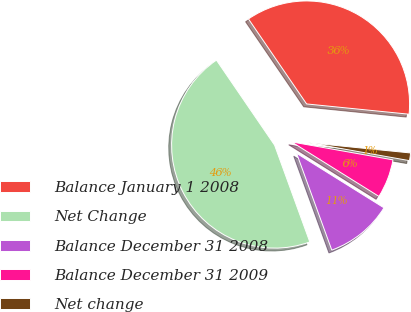Convert chart to OTSL. <chart><loc_0><loc_0><loc_500><loc_500><pie_chart><fcel>Balance January 1 2008<fcel>Net Change<fcel>Balance December 31 2008<fcel>Balance December 31 2009<fcel>Net change<nl><fcel>36.14%<fcel>46.01%<fcel>10.57%<fcel>6.09%<fcel>1.2%<nl></chart> 